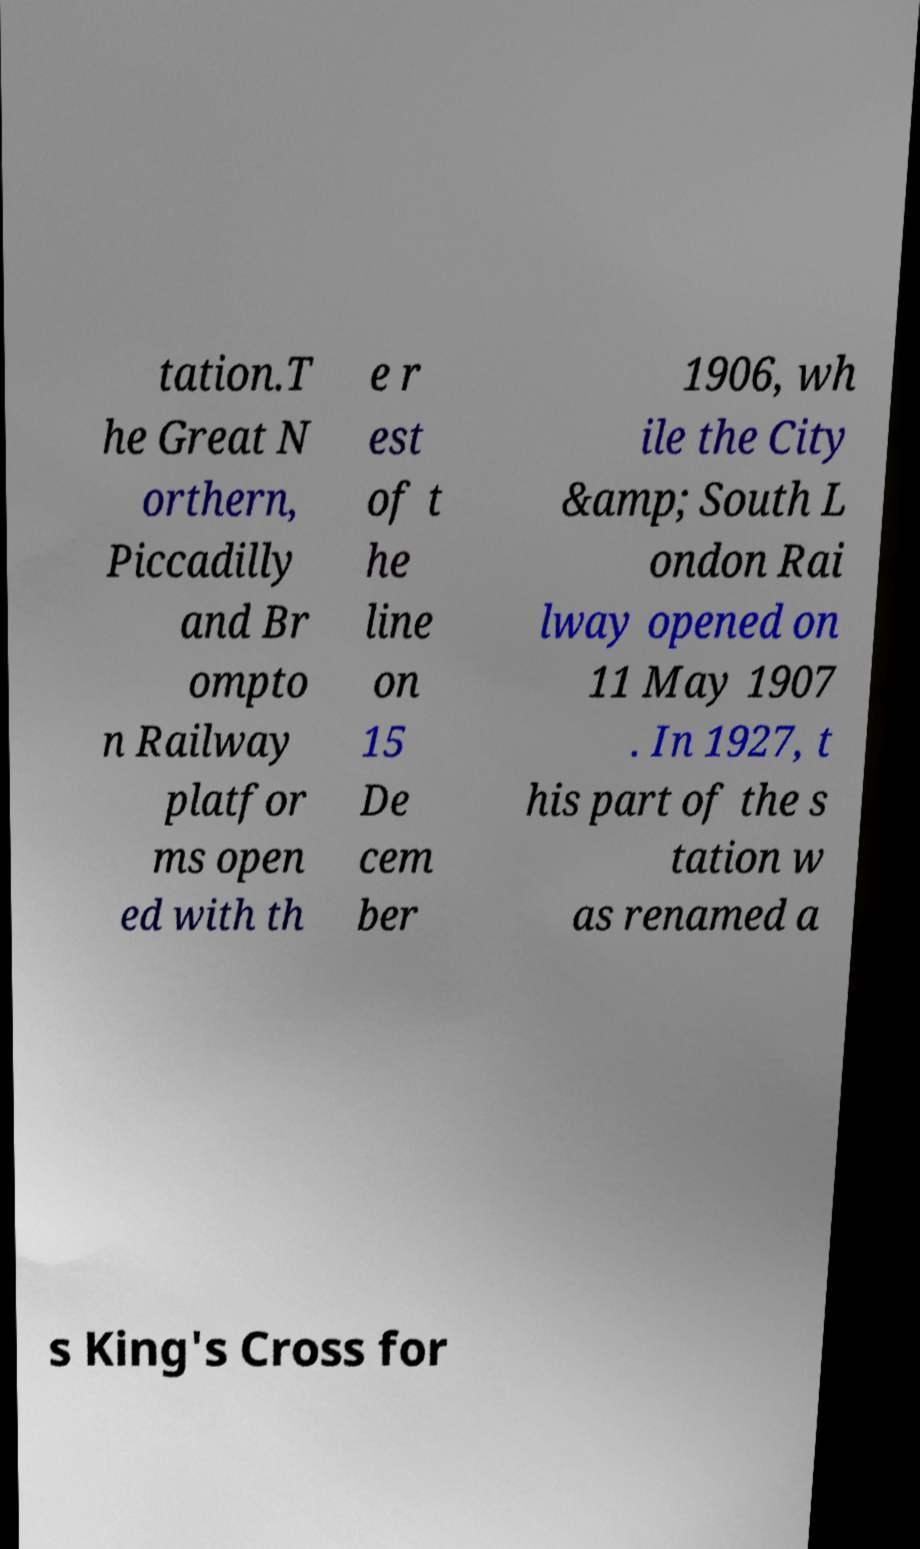I need the written content from this picture converted into text. Can you do that? tation.T he Great N orthern, Piccadilly and Br ompto n Railway platfor ms open ed with th e r est of t he line on 15 De cem ber 1906, wh ile the City &amp; South L ondon Rai lway opened on 11 May 1907 . In 1927, t his part of the s tation w as renamed a s King's Cross for 